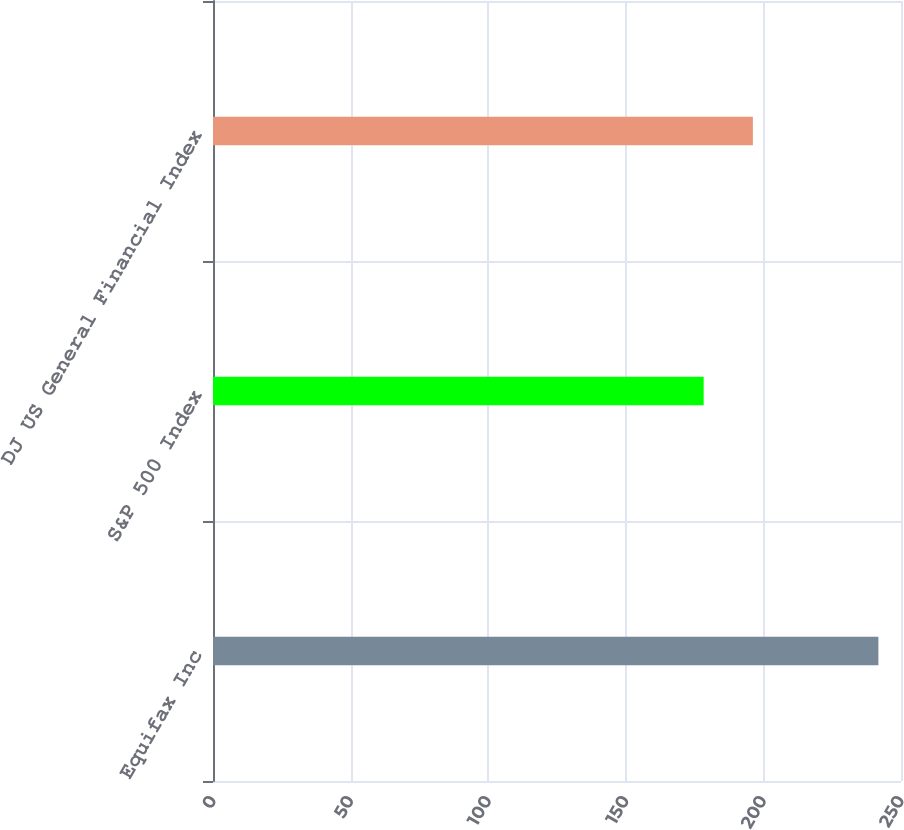Convert chart to OTSL. <chart><loc_0><loc_0><loc_500><loc_500><bar_chart><fcel>Equifax Inc<fcel>S&P 500 Index<fcel>DJ US General Financial Index<nl><fcel>241.79<fcel>178.29<fcel>196.18<nl></chart> 